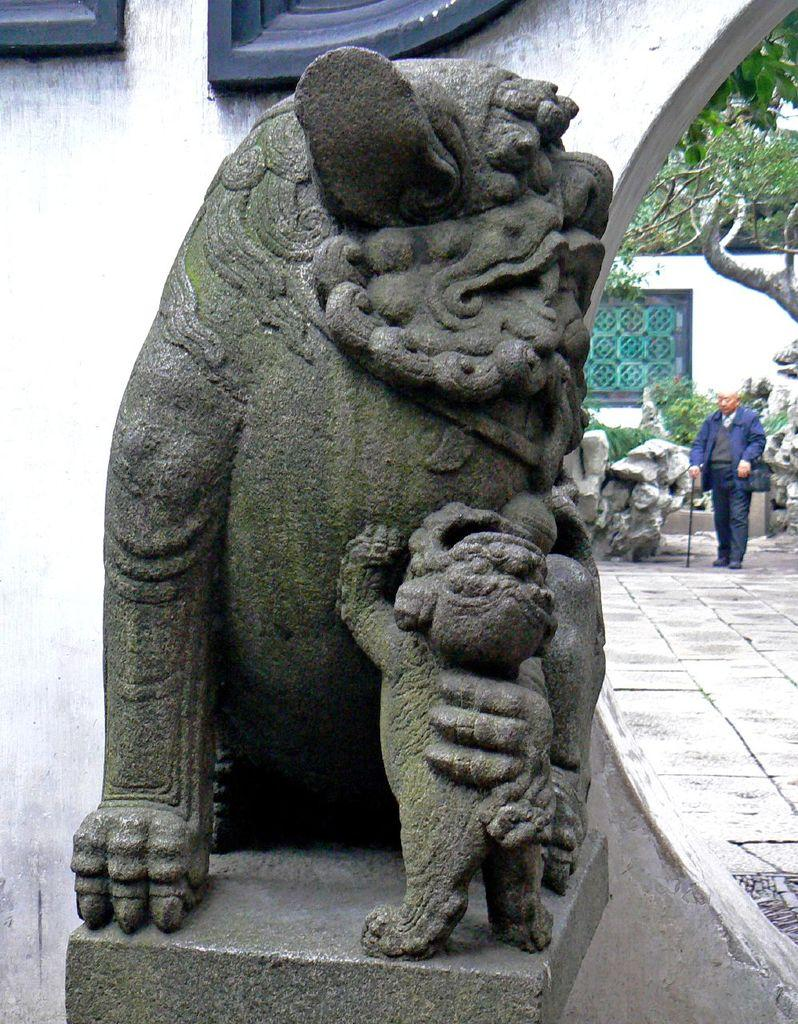What is the main subject in the image? There is a statue in the image. What is the man in the image doing? The man is holding a stick in the image. Where is the man standing? The man is standing on the ground in the image. What other objects or features can be seen in the image? Stones and a wall are present in the image. Trees are visible in the background of the image. What type of weather can be seen in the image? The image does not show any weather conditions; it only depicts a statue, a man, stones, a wall, and trees in the background. 